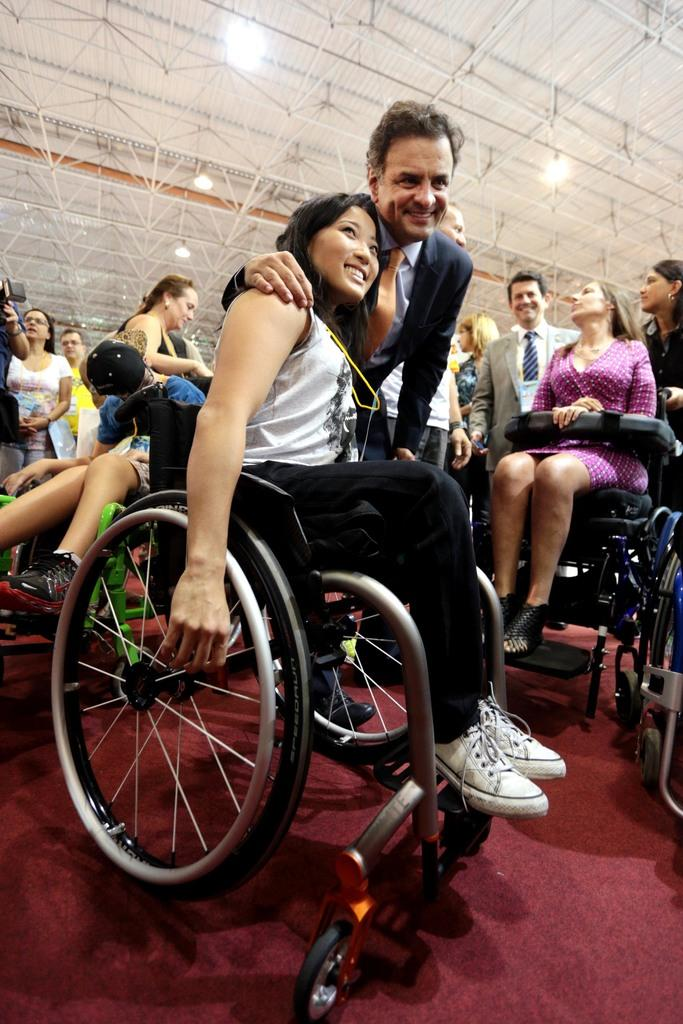Who or what can be seen in the image? There are people in the image. Can you describe the position or condition of some of the people? Some people are sitting on wheelchairs. What can be seen at the top of the image? There are lights visible at the top of the image. What type of food is being served to the people in the image? There is no food visible in the image. Can you describe the authority figure in the image? There is no authority figure mentioned or visible in the image. 